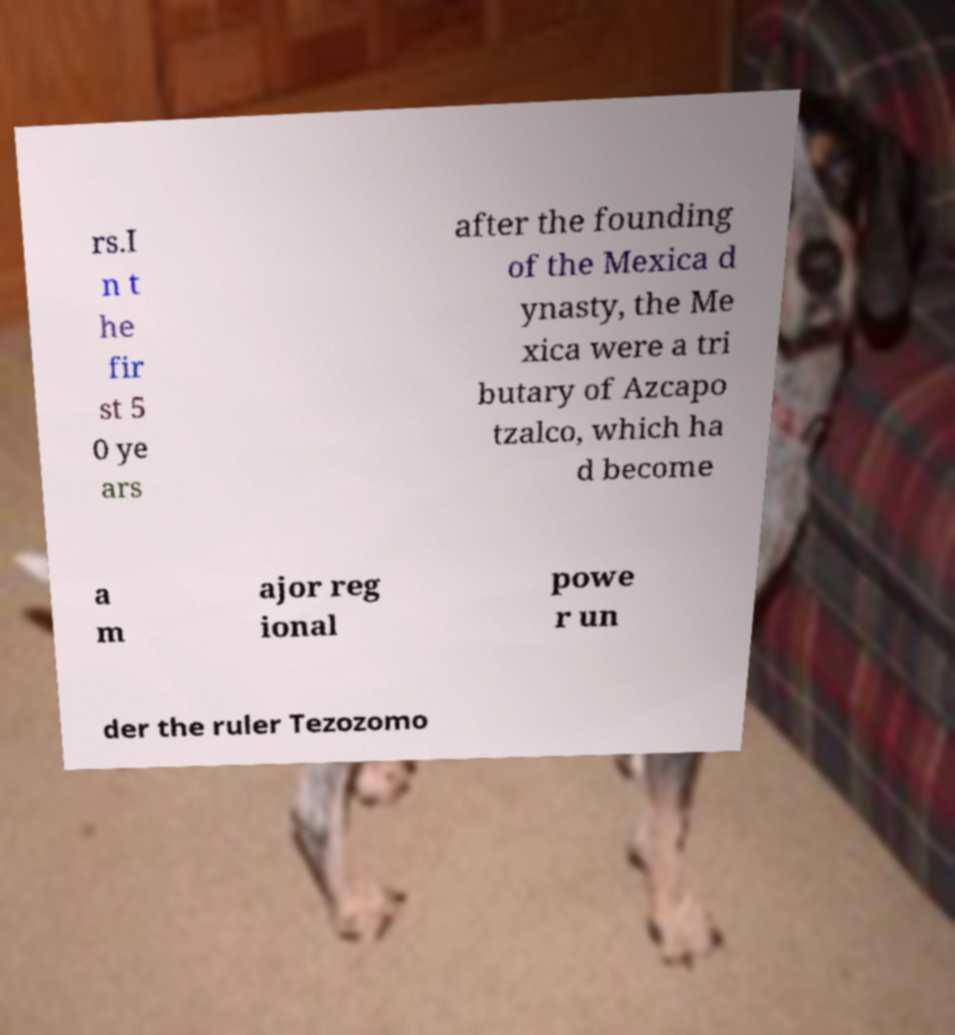Could you assist in decoding the text presented in this image and type it out clearly? rs.I n t he fir st 5 0 ye ars after the founding of the Mexica d ynasty, the Me xica were a tri butary of Azcapo tzalco, which ha d become a m ajor reg ional powe r un der the ruler Tezozomo 